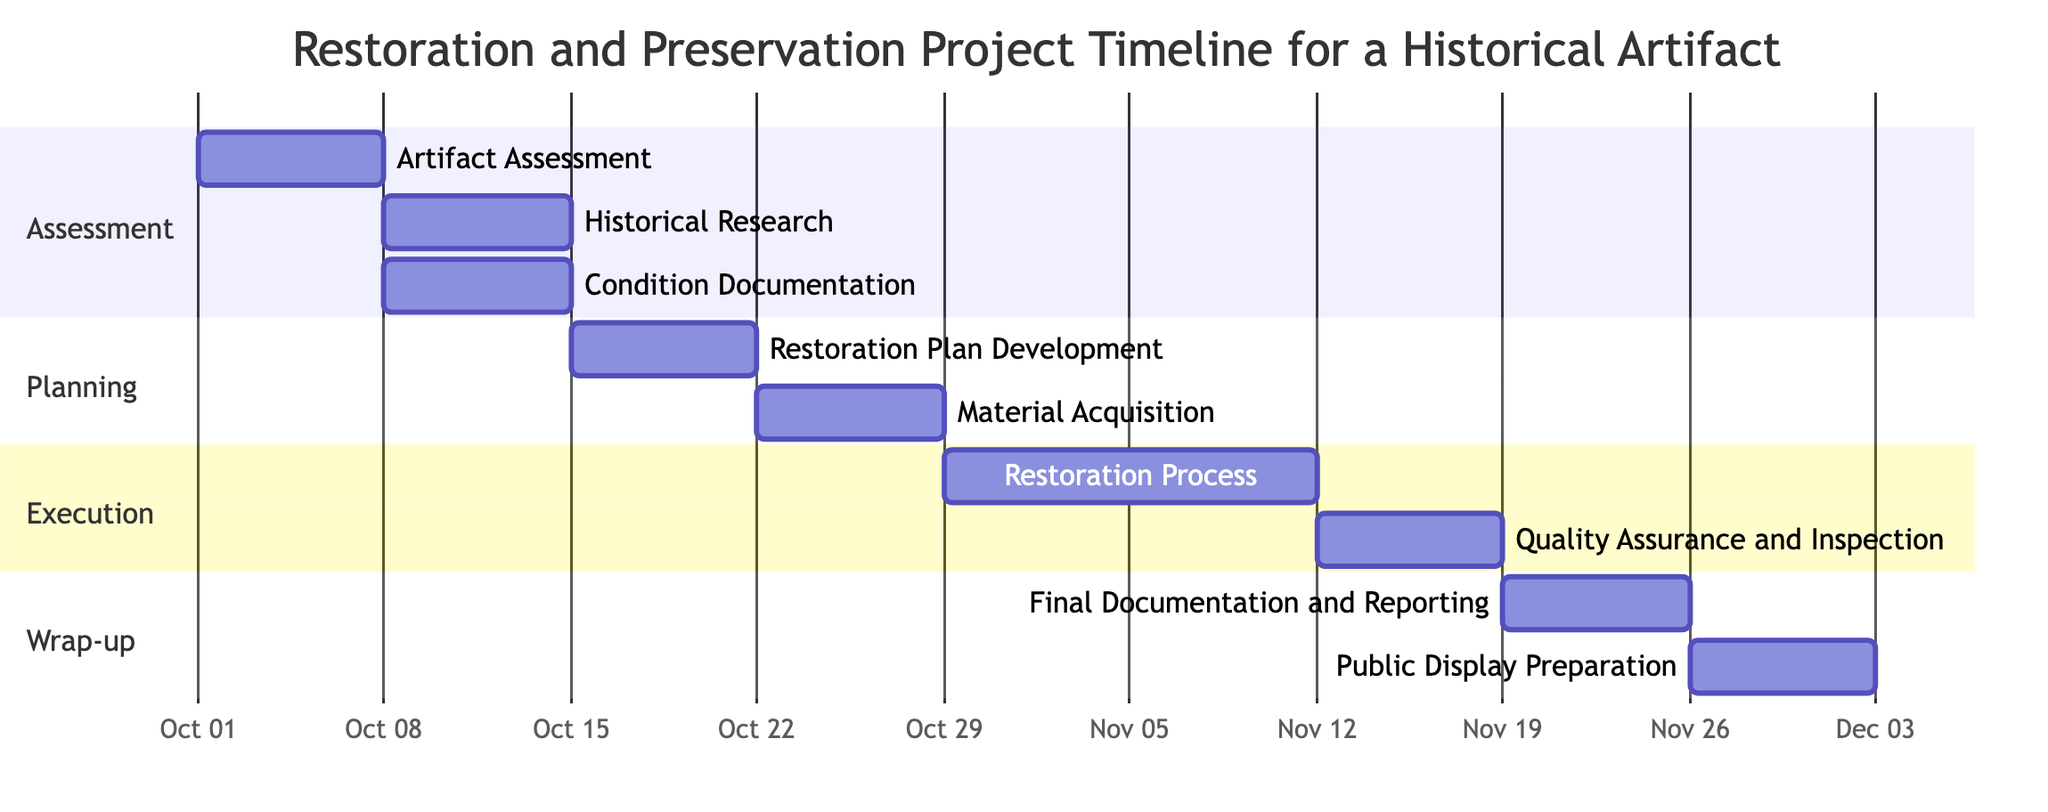What is the duration of the Artifact Assessment task? The Artifact Assessment task starts on October 1, 2023, and ends on October 7, 2023. The duration can be calculated as the difference between the end date and start date, which is 7 days.
Answer: 7 days Which task follows the Condition Documentation task? The Condition Documentation task ends on October 21, 2023. The next task in the timeline, Restoration Plan Development, starts immediately after its completion, which is on October 22, 2023.
Answer: Restoration Plan Development How many tasks are there in the Execution section? The Execution section consists of two tasks: Restoration Process and Quality Assurance and Inspection. Counting these gives a total of 2 tasks in this section.
Answer: 2 tasks What is the start date of the Quality Assurance and Inspection task? To find the start date of Quality Assurance and Inspection, we observe that it begins after the Restoration Process task, which starts on November 5, 2023, and lasts for 14 days. Therefore, Quality Assurance and Inspection starts on November 19, 2023.
Answer: November 19, 2023 How many days are allocated for the entire project? The entire project starts on October 1, 2023, with the Artifact Assessment task and ends on December 9, 2023, with the Public Display Preparation task. To calculate the total duration, we find the difference between the start and end dates, which is 69 days.
Answer: 69 days How many dependencies exist for the Restoration Plan Development task? The Restoration Plan Development task has two dependencies: Historical Research and Condition Documentation. These dependencies must be completed before this task can start.
Answer: 2 dependencies What is the final task in the project timeline? The final task in the project timeline is identified by examining the tasks listed, specifically the last task which is Public Display Preparation, scheduled to finish on December 9, 2023.
Answer: Public Display Preparation Why can the Material Acquisition task not start until the Restoration Plan Development is completed? The task dependencies indicate that Material Acquisition has Restoration Plan Development as a prerequisite. This means it cannot begin until Restoration Plan Development is fully completed, ensuring that all necessary planning is in place.
Answer: It depends on Restoration Plan Development 